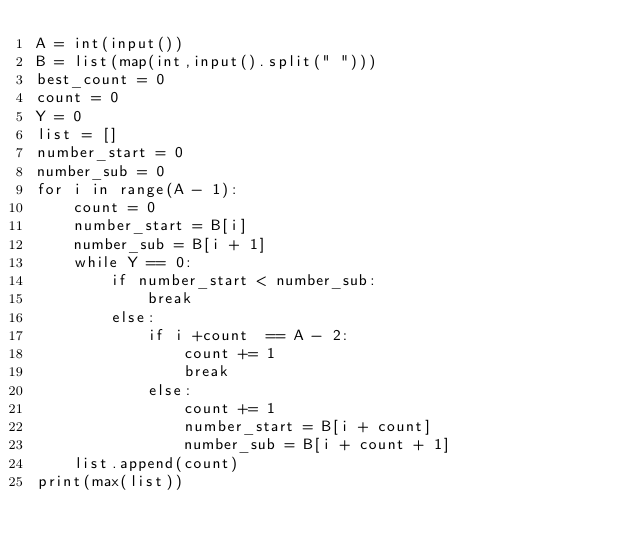Convert code to text. <code><loc_0><loc_0><loc_500><loc_500><_Python_>A = int(input())
B = list(map(int,input().split(" ")))
best_count = 0
count = 0
Y = 0
list = []
number_start = 0
number_sub = 0
for i in range(A - 1):
    count = 0
    number_start = B[i]
    number_sub = B[i + 1]
    while Y == 0:
        if number_start < number_sub:
            break
        else:
            if i +count  == A - 2:
                count += 1
                break
            else:
                count += 1
                number_start = B[i + count]
                number_sub = B[i + count + 1]  
    list.append(count)
print(max(list))</code> 